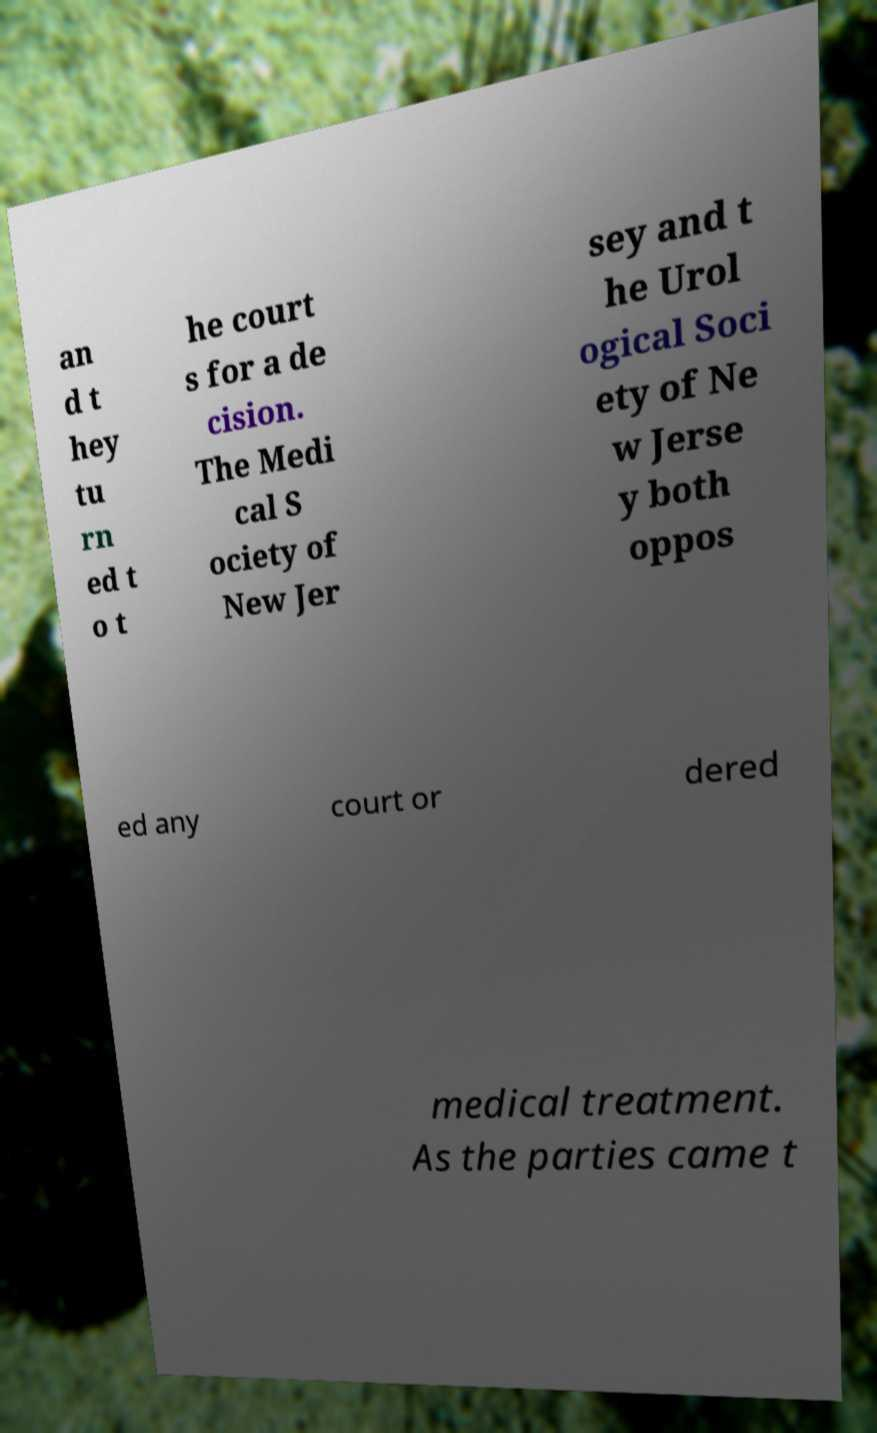For documentation purposes, I need the text within this image transcribed. Could you provide that? an d t hey tu rn ed t o t he court s for a de cision. The Medi cal S ociety of New Jer sey and t he Urol ogical Soci ety of Ne w Jerse y both oppos ed any court or dered medical treatment. As the parties came t 